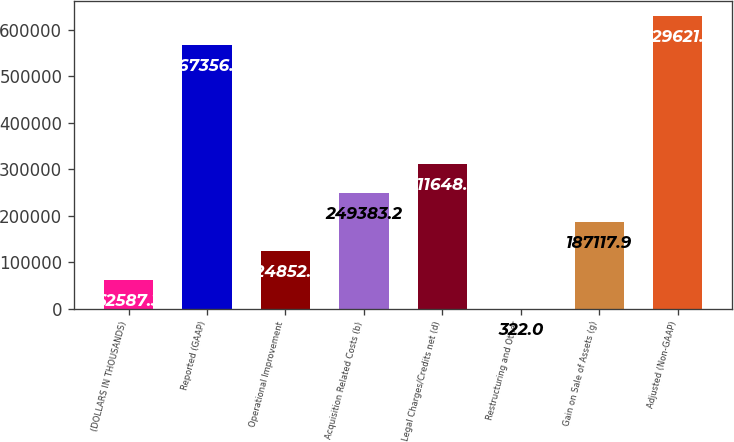<chart> <loc_0><loc_0><loc_500><loc_500><bar_chart><fcel>(DOLLARS IN THOUSANDS)<fcel>Reported (GAAP)<fcel>Operational Improvement<fcel>Acquisition Related Costs (b)<fcel>Legal Charges/Credits net (d)<fcel>Restructuring and Other<fcel>Gain on Sale of Assets (g)<fcel>Adjusted (Non-GAAP)<nl><fcel>62587.3<fcel>567356<fcel>124853<fcel>249383<fcel>311648<fcel>322<fcel>187118<fcel>629621<nl></chart> 